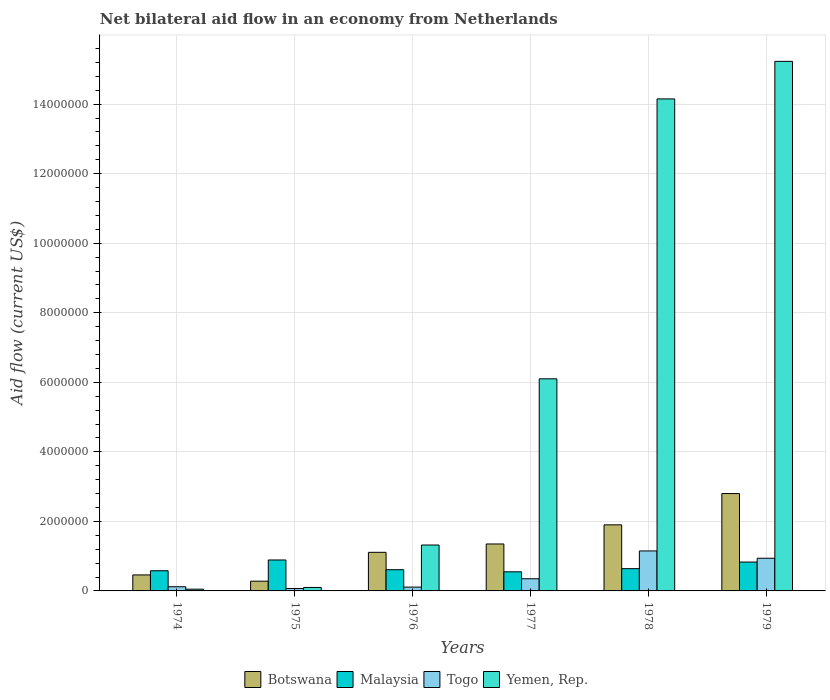Are the number of bars per tick equal to the number of legend labels?
Your answer should be compact. Yes. Are the number of bars on each tick of the X-axis equal?
Your response must be concise. Yes. How many bars are there on the 3rd tick from the left?
Ensure brevity in your answer.  4. How many bars are there on the 6th tick from the right?
Offer a terse response. 4. What is the label of the 2nd group of bars from the left?
Your answer should be compact. 1975. In how many cases, is the number of bars for a given year not equal to the number of legend labels?
Your answer should be compact. 0. Across all years, what is the maximum net bilateral aid flow in Togo?
Your answer should be compact. 1.15e+06. Across all years, what is the minimum net bilateral aid flow in Botswana?
Give a very brief answer. 2.80e+05. In which year was the net bilateral aid flow in Botswana maximum?
Provide a short and direct response. 1979. In which year was the net bilateral aid flow in Yemen, Rep. minimum?
Provide a short and direct response. 1974. What is the total net bilateral aid flow in Malaysia in the graph?
Your response must be concise. 4.10e+06. What is the difference between the net bilateral aid flow in Malaysia in 1975 and that in 1977?
Make the answer very short. 3.40e+05. What is the difference between the net bilateral aid flow in Togo in 1978 and the net bilateral aid flow in Botswana in 1979?
Make the answer very short. -1.65e+06. What is the average net bilateral aid flow in Togo per year?
Offer a terse response. 4.57e+05. What is the ratio of the net bilateral aid flow in Botswana in 1974 to that in 1978?
Your answer should be very brief. 0.24. Is the difference between the net bilateral aid flow in Malaysia in 1975 and 1977 greater than the difference between the net bilateral aid flow in Togo in 1975 and 1977?
Ensure brevity in your answer.  Yes. What is the difference between the highest and the second highest net bilateral aid flow in Yemen, Rep.?
Your answer should be very brief. 1.08e+06. What is the difference between the highest and the lowest net bilateral aid flow in Botswana?
Offer a terse response. 2.52e+06. In how many years, is the net bilateral aid flow in Botswana greater than the average net bilateral aid flow in Botswana taken over all years?
Provide a short and direct response. 3. Is the sum of the net bilateral aid flow in Botswana in 1974 and 1977 greater than the maximum net bilateral aid flow in Malaysia across all years?
Give a very brief answer. Yes. What does the 3rd bar from the left in 1979 represents?
Offer a very short reply. Togo. What does the 3rd bar from the right in 1979 represents?
Your answer should be compact. Malaysia. How many bars are there?
Offer a very short reply. 24. How many years are there in the graph?
Provide a short and direct response. 6. What is the difference between two consecutive major ticks on the Y-axis?
Ensure brevity in your answer.  2.00e+06. Are the values on the major ticks of Y-axis written in scientific E-notation?
Provide a short and direct response. No. What is the title of the graph?
Give a very brief answer. Net bilateral aid flow in an economy from Netherlands. What is the label or title of the Y-axis?
Your answer should be very brief. Aid flow (current US$). What is the Aid flow (current US$) of Botswana in 1974?
Offer a terse response. 4.60e+05. What is the Aid flow (current US$) in Malaysia in 1974?
Your response must be concise. 5.80e+05. What is the Aid flow (current US$) of Togo in 1974?
Your response must be concise. 1.20e+05. What is the Aid flow (current US$) of Yemen, Rep. in 1974?
Offer a terse response. 5.00e+04. What is the Aid flow (current US$) of Botswana in 1975?
Provide a succinct answer. 2.80e+05. What is the Aid flow (current US$) in Malaysia in 1975?
Offer a very short reply. 8.90e+05. What is the Aid flow (current US$) of Togo in 1975?
Offer a terse response. 7.00e+04. What is the Aid flow (current US$) of Botswana in 1976?
Offer a terse response. 1.11e+06. What is the Aid flow (current US$) in Yemen, Rep. in 1976?
Keep it short and to the point. 1.32e+06. What is the Aid flow (current US$) of Botswana in 1977?
Provide a short and direct response. 1.35e+06. What is the Aid flow (current US$) of Malaysia in 1977?
Keep it short and to the point. 5.50e+05. What is the Aid flow (current US$) of Yemen, Rep. in 1977?
Your answer should be very brief. 6.10e+06. What is the Aid flow (current US$) in Botswana in 1978?
Provide a succinct answer. 1.90e+06. What is the Aid flow (current US$) in Malaysia in 1978?
Provide a short and direct response. 6.40e+05. What is the Aid flow (current US$) of Togo in 1978?
Offer a very short reply. 1.15e+06. What is the Aid flow (current US$) in Yemen, Rep. in 1978?
Provide a succinct answer. 1.42e+07. What is the Aid flow (current US$) of Botswana in 1979?
Your answer should be compact. 2.80e+06. What is the Aid flow (current US$) of Malaysia in 1979?
Keep it short and to the point. 8.30e+05. What is the Aid flow (current US$) in Togo in 1979?
Offer a very short reply. 9.40e+05. What is the Aid flow (current US$) of Yemen, Rep. in 1979?
Make the answer very short. 1.52e+07. Across all years, what is the maximum Aid flow (current US$) in Botswana?
Ensure brevity in your answer.  2.80e+06. Across all years, what is the maximum Aid flow (current US$) of Malaysia?
Offer a very short reply. 8.90e+05. Across all years, what is the maximum Aid flow (current US$) in Togo?
Give a very brief answer. 1.15e+06. Across all years, what is the maximum Aid flow (current US$) of Yemen, Rep.?
Offer a very short reply. 1.52e+07. Across all years, what is the minimum Aid flow (current US$) in Botswana?
Ensure brevity in your answer.  2.80e+05. Across all years, what is the minimum Aid flow (current US$) of Togo?
Your response must be concise. 7.00e+04. What is the total Aid flow (current US$) of Botswana in the graph?
Provide a short and direct response. 7.90e+06. What is the total Aid flow (current US$) of Malaysia in the graph?
Make the answer very short. 4.10e+06. What is the total Aid flow (current US$) in Togo in the graph?
Offer a terse response. 2.74e+06. What is the total Aid flow (current US$) in Yemen, Rep. in the graph?
Provide a succinct answer. 3.70e+07. What is the difference between the Aid flow (current US$) of Botswana in 1974 and that in 1975?
Provide a short and direct response. 1.80e+05. What is the difference between the Aid flow (current US$) in Malaysia in 1974 and that in 1975?
Give a very brief answer. -3.10e+05. What is the difference between the Aid flow (current US$) in Botswana in 1974 and that in 1976?
Your answer should be compact. -6.50e+05. What is the difference between the Aid flow (current US$) of Malaysia in 1974 and that in 1976?
Your answer should be very brief. -3.00e+04. What is the difference between the Aid flow (current US$) of Yemen, Rep. in 1974 and that in 1976?
Offer a terse response. -1.27e+06. What is the difference between the Aid flow (current US$) of Botswana in 1974 and that in 1977?
Keep it short and to the point. -8.90e+05. What is the difference between the Aid flow (current US$) in Yemen, Rep. in 1974 and that in 1977?
Offer a very short reply. -6.05e+06. What is the difference between the Aid flow (current US$) of Botswana in 1974 and that in 1978?
Keep it short and to the point. -1.44e+06. What is the difference between the Aid flow (current US$) of Togo in 1974 and that in 1978?
Your answer should be very brief. -1.03e+06. What is the difference between the Aid flow (current US$) in Yemen, Rep. in 1974 and that in 1978?
Your answer should be compact. -1.41e+07. What is the difference between the Aid flow (current US$) in Botswana in 1974 and that in 1979?
Your answer should be very brief. -2.34e+06. What is the difference between the Aid flow (current US$) in Togo in 1974 and that in 1979?
Provide a succinct answer. -8.20e+05. What is the difference between the Aid flow (current US$) of Yemen, Rep. in 1974 and that in 1979?
Give a very brief answer. -1.52e+07. What is the difference between the Aid flow (current US$) in Botswana in 1975 and that in 1976?
Offer a terse response. -8.30e+05. What is the difference between the Aid flow (current US$) of Malaysia in 1975 and that in 1976?
Keep it short and to the point. 2.80e+05. What is the difference between the Aid flow (current US$) in Yemen, Rep. in 1975 and that in 1976?
Your answer should be very brief. -1.22e+06. What is the difference between the Aid flow (current US$) in Botswana in 1975 and that in 1977?
Offer a very short reply. -1.07e+06. What is the difference between the Aid flow (current US$) in Malaysia in 1975 and that in 1977?
Make the answer very short. 3.40e+05. What is the difference between the Aid flow (current US$) in Togo in 1975 and that in 1977?
Your response must be concise. -2.80e+05. What is the difference between the Aid flow (current US$) in Yemen, Rep. in 1975 and that in 1977?
Your response must be concise. -6.00e+06. What is the difference between the Aid flow (current US$) in Botswana in 1975 and that in 1978?
Offer a terse response. -1.62e+06. What is the difference between the Aid flow (current US$) of Malaysia in 1975 and that in 1978?
Provide a short and direct response. 2.50e+05. What is the difference between the Aid flow (current US$) of Togo in 1975 and that in 1978?
Offer a terse response. -1.08e+06. What is the difference between the Aid flow (current US$) of Yemen, Rep. in 1975 and that in 1978?
Offer a very short reply. -1.40e+07. What is the difference between the Aid flow (current US$) in Botswana in 1975 and that in 1979?
Provide a succinct answer. -2.52e+06. What is the difference between the Aid flow (current US$) of Togo in 1975 and that in 1979?
Offer a terse response. -8.70e+05. What is the difference between the Aid flow (current US$) of Yemen, Rep. in 1975 and that in 1979?
Offer a very short reply. -1.51e+07. What is the difference between the Aid flow (current US$) in Botswana in 1976 and that in 1977?
Offer a terse response. -2.40e+05. What is the difference between the Aid flow (current US$) in Yemen, Rep. in 1976 and that in 1977?
Make the answer very short. -4.78e+06. What is the difference between the Aid flow (current US$) of Botswana in 1976 and that in 1978?
Provide a short and direct response. -7.90e+05. What is the difference between the Aid flow (current US$) in Togo in 1976 and that in 1978?
Your response must be concise. -1.04e+06. What is the difference between the Aid flow (current US$) in Yemen, Rep. in 1976 and that in 1978?
Offer a terse response. -1.28e+07. What is the difference between the Aid flow (current US$) of Botswana in 1976 and that in 1979?
Your answer should be very brief. -1.69e+06. What is the difference between the Aid flow (current US$) of Malaysia in 1976 and that in 1979?
Your answer should be very brief. -2.20e+05. What is the difference between the Aid flow (current US$) in Togo in 1976 and that in 1979?
Offer a terse response. -8.30e+05. What is the difference between the Aid flow (current US$) in Yemen, Rep. in 1976 and that in 1979?
Your answer should be very brief. -1.39e+07. What is the difference between the Aid flow (current US$) of Botswana in 1977 and that in 1978?
Provide a short and direct response. -5.50e+05. What is the difference between the Aid flow (current US$) of Togo in 1977 and that in 1978?
Your answer should be compact. -8.00e+05. What is the difference between the Aid flow (current US$) in Yemen, Rep. in 1977 and that in 1978?
Ensure brevity in your answer.  -8.05e+06. What is the difference between the Aid flow (current US$) in Botswana in 1977 and that in 1979?
Provide a succinct answer. -1.45e+06. What is the difference between the Aid flow (current US$) of Malaysia in 1977 and that in 1979?
Make the answer very short. -2.80e+05. What is the difference between the Aid flow (current US$) in Togo in 1977 and that in 1979?
Give a very brief answer. -5.90e+05. What is the difference between the Aid flow (current US$) in Yemen, Rep. in 1977 and that in 1979?
Provide a short and direct response. -9.13e+06. What is the difference between the Aid flow (current US$) in Botswana in 1978 and that in 1979?
Provide a short and direct response. -9.00e+05. What is the difference between the Aid flow (current US$) in Malaysia in 1978 and that in 1979?
Keep it short and to the point. -1.90e+05. What is the difference between the Aid flow (current US$) in Togo in 1978 and that in 1979?
Your answer should be very brief. 2.10e+05. What is the difference between the Aid flow (current US$) of Yemen, Rep. in 1978 and that in 1979?
Your answer should be very brief. -1.08e+06. What is the difference between the Aid flow (current US$) of Botswana in 1974 and the Aid flow (current US$) of Malaysia in 1975?
Keep it short and to the point. -4.30e+05. What is the difference between the Aid flow (current US$) in Botswana in 1974 and the Aid flow (current US$) in Togo in 1975?
Ensure brevity in your answer.  3.90e+05. What is the difference between the Aid flow (current US$) of Malaysia in 1974 and the Aid flow (current US$) of Togo in 1975?
Your response must be concise. 5.10e+05. What is the difference between the Aid flow (current US$) of Togo in 1974 and the Aid flow (current US$) of Yemen, Rep. in 1975?
Offer a very short reply. 2.00e+04. What is the difference between the Aid flow (current US$) in Botswana in 1974 and the Aid flow (current US$) in Yemen, Rep. in 1976?
Offer a very short reply. -8.60e+05. What is the difference between the Aid flow (current US$) of Malaysia in 1974 and the Aid flow (current US$) of Togo in 1976?
Your response must be concise. 4.70e+05. What is the difference between the Aid flow (current US$) in Malaysia in 1974 and the Aid flow (current US$) in Yemen, Rep. in 1976?
Offer a very short reply. -7.40e+05. What is the difference between the Aid flow (current US$) of Togo in 1974 and the Aid flow (current US$) of Yemen, Rep. in 1976?
Your response must be concise. -1.20e+06. What is the difference between the Aid flow (current US$) in Botswana in 1974 and the Aid flow (current US$) in Togo in 1977?
Offer a terse response. 1.10e+05. What is the difference between the Aid flow (current US$) in Botswana in 1974 and the Aid flow (current US$) in Yemen, Rep. in 1977?
Your answer should be compact. -5.64e+06. What is the difference between the Aid flow (current US$) in Malaysia in 1974 and the Aid flow (current US$) in Togo in 1977?
Your answer should be very brief. 2.30e+05. What is the difference between the Aid flow (current US$) in Malaysia in 1974 and the Aid flow (current US$) in Yemen, Rep. in 1977?
Your response must be concise. -5.52e+06. What is the difference between the Aid flow (current US$) of Togo in 1974 and the Aid flow (current US$) of Yemen, Rep. in 1977?
Keep it short and to the point. -5.98e+06. What is the difference between the Aid flow (current US$) of Botswana in 1974 and the Aid flow (current US$) of Malaysia in 1978?
Give a very brief answer. -1.80e+05. What is the difference between the Aid flow (current US$) in Botswana in 1974 and the Aid flow (current US$) in Togo in 1978?
Provide a short and direct response. -6.90e+05. What is the difference between the Aid flow (current US$) of Botswana in 1974 and the Aid flow (current US$) of Yemen, Rep. in 1978?
Keep it short and to the point. -1.37e+07. What is the difference between the Aid flow (current US$) in Malaysia in 1974 and the Aid flow (current US$) in Togo in 1978?
Your answer should be compact. -5.70e+05. What is the difference between the Aid flow (current US$) of Malaysia in 1974 and the Aid flow (current US$) of Yemen, Rep. in 1978?
Offer a very short reply. -1.36e+07. What is the difference between the Aid flow (current US$) in Togo in 1974 and the Aid flow (current US$) in Yemen, Rep. in 1978?
Keep it short and to the point. -1.40e+07. What is the difference between the Aid flow (current US$) in Botswana in 1974 and the Aid flow (current US$) in Malaysia in 1979?
Your response must be concise. -3.70e+05. What is the difference between the Aid flow (current US$) of Botswana in 1974 and the Aid flow (current US$) of Togo in 1979?
Provide a succinct answer. -4.80e+05. What is the difference between the Aid flow (current US$) of Botswana in 1974 and the Aid flow (current US$) of Yemen, Rep. in 1979?
Provide a short and direct response. -1.48e+07. What is the difference between the Aid flow (current US$) in Malaysia in 1974 and the Aid flow (current US$) in Togo in 1979?
Your answer should be very brief. -3.60e+05. What is the difference between the Aid flow (current US$) in Malaysia in 1974 and the Aid flow (current US$) in Yemen, Rep. in 1979?
Ensure brevity in your answer.  -1.46e+07. What is the difference between the Aid flow (current US$) of Togo in 1974 and the Aid flow (current US$) of Yemen, Rep. in 1979?
Make the answer very short. -1.51e+07. What is the difference between the Aid flow (current US$) of Botswana in 1975 and the Aid flow (current US$) of Malaysia in 1976?
Provide a short and direct response. -3.30e+05. What is the difference between the Aid flow (current US$) of Botswana in 1975 and the Aid flow (current US$) of Togo in 1976?
Your answer should be very brief. 1.70e+05. What is the difference between the Aid flow (current US$) in Botswana in 1975 and the Aid flow (current US$) in Yemen, Rep. in 1976?
Give a very brief answer. -1.04e+06. What is the difference between the Aid flow (current US$) of Malaysia in 1975 and the Aid flow (current US$) of Togo in 1976?
Ensure brevity in your answer.  7.80e+05. What is the difference between the Aid flow (current US$) in Malaysia in 1975 and the Aid flow (current US$) in Yemen, Rep. in 1976?
Provide a short and direct response. -4.30e+05. What is the difference between the Aid flow (current US$) in Togo in 1975 and the Aid flow (current US$) in Yemen, Rep. in 1976?
Keep it short and to the point. -1.25e+06. What is the difference between the Aid flow (current US$) of Botswana in 1975 and the Aid flow (current US$) of Malaysia in 1977?
Your response must be concise. -2.70e+05. What is the difference between the Aid flow (current US$) of Botswana in 1975 and the Aid flow (current US$) of Togo in 1977?
Make the answer very short. -7.00e+04. What is the difference between the Aid flow (current US$) in Botswana in 1975 and the Aid flow (current US$) in Yemen, Rep. in 1977?
Ensure brevity in your answer.  -5.82e+06. What is the difference between the Aid flow (current US$) in Malaysia in 1975 and the Aid flow (current US$) in Togo in 1977?
Keep it short and to the point. 5.40e+05. What is the difference between the Aid flow (current US$) of Malaysia in 1975 and the Aid flow (current US$) of Yemen, Rep. in 1977?
Make the answer very short. -5.21e+06. What is the difference between the Aid flow (current US$) in Togo in 1975 and the Aid flow (current US$) in Yemen, Rep. in 1977?
Provide a short and direct response. -6.03e+06. What is the difference between the Aid flow (current US$) in Botswana in 1975 and the Aid flow (current US$) in Malaysia in 1978?
Make the answer very short. -3.60e+05. What is the difference between the Aid flow (current US$) of Botswana in 1975 and the Aid flow (current US$) of Togo in 1978?
Your answer should be compact. -8.70e+05. What is the difference between the Aid flow (current US$) in Botswana in 1975 and the Aid flow (current US$) in Yemen, Rep. in 1978?
Give a very brief answer. -1.39e+07. What is the difference between the Aid flow (current US$) in Malaysia in 1975 and the Aid flow (current US$) in Yemen, Rep. in 1978?
Give a very brief answer. -1.33e+07. What is the difference between the Aid flow (current US$) in Togo in 1975 and the Aid flow (current US$) in Yemen, Rep. in 1978?
Provide a short and direct response. -1.41e+07. What is the difference between the Aid flow (current US$) in Botswana in 1975 and the Aid flow (current US$) in Malaysia in 1979?
Ensure brevity in your answer.  -5.50e+05. What is the difference between the Aid flow (current US$) of Botswana in 1975 and the Aid flow (current US$) of Togo in 1979?
Offer a very short reply. -6.60e+05. What is the difference between the Aid flow (current US$) of Botswana in 1975 and the Aid flow (current US$) of Yemen, Rep. in 1979?
Provide a succinct answer. -1.50e+07. What is the difference between the Aid flow (current US$) of Malaysia in 1975 and the Aid flow (current US$) of Yemen, Rep. in 1979?
Provide a succinct answer. -1.43e+07. What is the difference between the Aid flow (current US$) in Togo in 1975 and the Aid flow (current US$) in Yemen, Rep. in 1979?
Your answer should be compact. -1.52e+07. What is the difference between the Aid flow (current US$) of Botswana in 1976 and the Aid flow (current US$) of Malaysia in 1977?
Ensure brevity in your answer.  5.60e+05. What is the difference between the Aid flow (current US$) of Botswana in 1976 and the Aid flow (current US$) of Togo in 1977?
Your response must be concise. 7.60e+05. What is the difference between the Aid flow (current US$) in Botswana in 1976 and the Aid flow (current US$) in Yemen, Rep. in 1977?
Your response must be concise. -4.99e+06. What is the difference between the Aid flow (current US$) of Malaysia in 1976 and the Aid flow (current US$) of Yemen, Rep. in 1977?
Your answer should be compact. -5.49e+06. What is the difference between the Aid flow (current US$) in Togo in 1976 and the Aid flow (current US$) in Yemen, Rep. in 1977?
Give a very brief answer. -5.99e+06. What is the difference between the Aid flow (current US$) of Botswana in 1976 and the Aid flow (current US$) of Malaysia in 1978?
Your response must be concise. 4.70e+05. What is the difference between the Aid flow (current US$) of Botswana in 1976 and the Aid flow (current US$) of Yemen, Rep. in 1978?
Offer a very short reply. -1.30e+07. What is the difference between the Aid flow (current US$) in Malaysia in 1976 and the Aid flow (current US$) in Togo in 1978?
Give a very brief answer. -5.40e+05. What is the difference between the Aid flow (current US$) in Malaysia in 1976 and the Aid flow (current US$) in Yemen, Rep. in 1978?
Offer a terse response. -1.35e+07. What is the difference between the Aid flow (current US$) of Togo in 1976 and the Aid flow (current US$) of Yemen, Rep. in 1978?
Your answer should be compact. -1.40e+07. What is the difference between the Aid flow (current US$) in Botswana in 1976 and the Aid flow (current US$) in Malaysia in 1979?
Give a very brief answer. 2.80e+05. What is the difference between the Aid flow (current US$) in Botswana in 1976 and the Aid flow (current US$) in Yemen, Rep. in 1979?
Keep it short and to the point. -1.41e+07. What is the difference between the Aid flow (current US$) of Malaysia in 1976 and the Aid flow (current US$) of Togo in 1979?
Provide a succinct answer. -3.30e+05. What is the difference between the Aid flow (current US$) of Malaysia in 1976 and the Aid flow (current US$) of Yemen, Rep. in 1979?
Provide a succinct answer. -1.46e+07. What is the difference between the Aid flow (current US$) of Togo in 1976 and the Aid flow (current US$) of Yemen, Rep. in 1979?
Offer a terse response. -1.51e+07. What is the difference between the Aid flow (current US$) of Botswana in 1977 and the Aid flow (current US$) of Malaysia in 1978?
Offer a terse response. 7.10e+05. What is the difference between the Aid flow (current US$) of Botswana in 1977 and the Aid flow (current US$) of Yemen, Rep. in 1978?
Make the answer very short. -1.28e+07. What is the difference between the Aid flow (current US$) in Malaysia in 1977 and the Aid flow (current US$) in Togo in 1978?
Your answer should be compact. -6.00e+05. What is the difference between the Aid flow (current US$) in Malaysia in 1977 and the Aid flow (current US$) in Yemen, Rep. in 1978?
Your answer should be very brief. -1.36e+07. What is the difference between the Aid flow (current US$) of Togo in 1977 and the Aid flow (current US$) of Yemen, Rep. in 1978?
Make the answer very short. -1.38e+07. What is the difference between the Aid flow (current US$) of Botswana in 1977 and the Aid flow (current US$) of Malaysia in 1979?
Ensure brevity in your answer.  5.20e+05. What is the difference between the Aid flow (current US$) in Botswana in 1977 and the Aid flow (current US$) in Togo in 1979?
Give a very brief answer. 4.10e+05. What is the difference between the Aid flow (current US$) in Botswana in 1977 and the Aid flow (current US$) in Yemen, Rep. in 1979?
Your answer should be compact. -1.39e+07. What is the difference between the Aid flow (current US$) of Malaysia in 1977 and the Aid flow (current US$) of Togo in 1979?
Offer a very short reply. -3.90e+05. What is the difference between the Aid flow (current US$) of Malaysia in 1977 and the Aid flow (current US$) of Yemen, Rep. in 1979?
Provide a succinct answer. -1.47e+07. What is the difference between the Aid flow (current US$) of Togo in 1977 and the Aid flow (current US$) of Yemen, Rep. in 1979?
Your answer should be very brief. -1.49e+07. What is the difference between the Aid flow (current US$) in Botswana in 1978 and the Aid flow (current US$) in Malaysia in 1979?
Provide a short and direct response. 1.07e+06. What is the difference between the Aid flow (current US$) of Botswana in 1978 and the Aid flow (current US$) of Togo in 1979?
Ensure brevity in your answer.  9.60e+05. What is the difference between the Aid flow (current US$) in Botswana in 1978 and the Aid flow (current US$) in Yemen, Rep. in 1979?
Give a very brief answer. -1.33e+07. What is the difference between the Aid flow (current US$) of Malaysia in 1978 and the Aid flow (current US$) of Togo in 1979?
Offer a terse response. -3.00e+05. What is the difference between the Aid flow (current US$) of Malaysia in 1978 and the Aid flow (current US$) of Yemen, Rep. in 1979?
Keep it short and to the point. -1.46e+07. What is the difference between the Aid flow (current US$) in Togo in 1978 and the Aid flow (current US$) in Yemen, Rep. in 1979?
Provide a short and direct response. -1.41e+07. What is the average Aid flow (current US$) in Botswana per year?
Make the answer very short. 1.32e+06. What is the average Aid flow (current US$) in Malaysia per year?
Ensure brevity in your answer.  6.83e+05. What is the average Aid flow (current US$) of Togo per year?
Provide a short and direct response. 4.57e+05. What is the average Aid flow (current US$) of Yemen, Rep. per year?
Provide a short and direct response. 6.16e+06. In the year 1974, what is the difference between the Aid flow (current US$) of Botswana and Aid flow (current US$) of Malaysia?
Your answer should be compact. -1.20e+05. In the year 1974, what is the difference between the Aid flow (current US$) of Botswana and Aid flow (current US$) of Yemen, Rep.?
Keep it short and to the point. 4.10e+05. In the year 1974, what is the difference between the Aid flow (current US$) in Malaysia and Aid flow (current US$) in Togo?
Your response must be concise. 4.60e+05. In the year 1974, what is the difference between the Aid flow (current US$) in Malaysia and Aid flow (current US$) in Yemen, Rep.?
Offer a terse response. 5.30e+05. In the year 1974, what is the difference between the Aid flow (current US$) of Togo and Aid flow (current US$) of Yemen, Rep.?
Give a very brief answer. 7.00e+04. In the year 1975, what is the difference between the Aid flow (current US$) of Botswana and Aid flow (current US$) of Malaysia?
Your response must be concise. -6.10e+05. In the year 1975, what is the difference between the Aid flow (current US$) in Malaysia and Aid flow (current US$) in Togo?
Ensure brevity in your answer.  8.20e+05. In the year 1975, what is the difference between the Aid flow (current US$) of Malaysia and Aid flow (current US$) of Yemen, Rep.?
Provide a short and direct response. 7.90e+05. In the year 1975, what is the difference between the Aid flow (current US$) in Togo and Aid flow (current US$) in Yemen, Rep.?
Give a very brief answer. -3.00e+04. In the year 1976, what is the difference between the Aid flow (current US$) in Botswana and Aid flow (current US$) in Togo?
Ensure brevity in your answer.  1.00e+06. In the year 1976, what is the difference between the Aid flow (current US$) in Botswana and Aid flow (current US$) in Yemen, Rep.?
Offer a terse response. -2.10e+05. In the year 1976, what is the difference between the Aid flow (current US$) of Malaysia and Aid flow (current US$) of Yemen, Rep.?
Make the answer very short. -7.10e+05. In the year 1976, what is the difference between the Aid flow (current US$) in Togo and Aid flow (current US$) in Yemen, Rep.?
Give a very brief answer. -1.21e+06. In the year 1977, what is the difference between the Aid flow (current US$) in Botswana and Aid flow (current US$) in Malaysia?
Ensure brevity in your answer.  8.00e+05. In the year 1977, what is the difference between the Aid flow (current US$) in Botswana and Aid flow (current US$) in Togo?
Give a very brief answer. 1.00e+06. In the year 1977, what is the difference between the Aid flow (current US$) of Botswana and Aid flow (current US$) of Yemen, Rep.?
Provide a short and direct response. -4.75e+06. In the year 1977, what is the difference between the Aid flow (current US$) of Malaysia and Aid flow (current US$) of Yemen, Rep.?
Offer a very short reply. -5.55e+06. In the year 1977, what is the difference between the Aid flow (current US$) in Togo and Aid flow (current US$) in Yemen, Rep.?
Ensure brevity in your answer.  -5.75e+06. In the year 1978, what is the difference between the Aid flow (current US$) of Botswana and Aid flow (current US$) of Malaysia?
Your answer should be compact. 1.26e+06. In the year 1978, what is the difference between the Aid flow (current US$) of Botswana and Aid flow (current US$) of Togo?
Your answer should be compact. 7.50e+05. In the year 1978, what is the difference between the Aid flow (current US$) in Botswana and Aid flow (current US$) in Yemen, Rep.?
Your response must be concise. -1.22e+07. In the year 1978, what is the difference between the Aid flow (current US$) of Malaysia and Aid flow (current US$) of Togo?
Provide a succinct answer. -5.10e+05. In the year 1978, what is the difference between the Aid flow (current US$) in Malaysia and Aid flow (current US$) in Yemen, Rep.?
Offer a terse response. -1.35e+07. In the year 1978, what is the difference between the Aid flow (current US$) of Togo and Aid flow (current US$) of Yemen, Rep.?
Keep it short and to the point. -1.30e+07. In the year 1979, what is the difference between the Aid flow (current US$) in Botswana and Aid flow (current US$) in Malaysia?
Give a very brief answer. 1.97e+06. In the year 1979, what is the difference between the Aid flow (current US$) in Botswana and Aid flow (current US$) in Togo?
Provide a short and direct response. 1.86e+06. In the year 1979, what is the difference between the Aid flow (current US$) of Botswana and Aid flow (current US$) of Yemen, Rep.?
Your answer should be compact. -1.24e+07. In the year 1979, what is the difference between the Aid flow (current US$) in Malaysia and Aid flow (current US$) in Yemen, Rep.?
Provide a short and direct response. -1.44e+07. In the year 1979, what is the difference between the Aid flow (current US$) of Togo and Aid flow (current US$) of Yemen, Rep.?
Make the answer very short. -1.43e+07. What is the ratio of the Aid flow (current US$) in Botswana in 1974 to that in 1975?
Offer a very short reply. 1.64. What is the ratio of the Aid flow (current US$) in Malaysia in 1974 to that in 1975?
Make the answer very short. 0.65. What is the ratio of the Aid flow (current US$) of Togo in 1974 to that in 1975?
Your response must be concise. 1.71. What is the ratio of the Aid flow (current US$) in Yemen, Rep. in 1974 to that in 1975?
Keep it short and to the point. 0.5. What is the ratio of the Aid flow (current US$) in Botswana in 1974 to that in 1976?
Keep it short and to the point. 0.41. What is the ratio of the Aid flow (current US$) in Malaysia in 1974 to that in 1976?
Your response must be concise. 0.95. What is the ratio of the Aid flow (current US$) of Togo in 1974 to that in 1976?
Give a very brief answer. 1.09. What is the ratio of the Aid flow (current US$) of Yemen, Rep. in 1974 to that in 1976?
Your response must be concise. 0.04. What is the ratio of the Aid flow (current US$) in Botswana in 1974 to that in 1977?
Ensure brevity in your answer.  0.34. What is the ratio of the Aid flow (current US$) of Malaysia in 1974 to that in 1977?
Provide a short and direct response. 1.05. What is the ratio of the Aid flow (current US$) of Togo in 1974 to that in 1977?
Keep it short and to the point. 0.34. What is the ratio of the Aid flow (current US$) of Yemen, Rep. in 1974 to that in 1977?
Keep it short and to the point. 0.01. What is the ratio of the Aid flow (current US$) in Botswana in 1974 to that in 1978?
Offer a very short reply. 0.24. What is the ratio of the Aid flow (current US$) in Malaysia in 1974 to that in 1978?
Keep it short and to the point. 0.91. What is the ratio of the Aid flow (current US$) of Togo in 1974 to that in 1978?
Ensure brevity in your answer.  0.1. What is the ratio of the Aid flow (current US$) of Yemen, Rep. in 1974 to that in 1978?
Your response must be concise. 0. What is the ratio of the Aid flow (current US$) of Botswana in 1974 to that in 1979?
Offer a terse response. 0.16. What is the ratio of the Aid flow (current US$) in Malaysia in 1974 to that in 1979?
Give a very brief answer. 0.7. What is the ratio of the Aid flow (current US$) of Togo in 1974 to that in 1979?
Make the answer very short. 0.13. What is the ratio of the Aid flow (current US$) of Yemen, Rep. in 1974 to that in 1979?
Keep it short and to the point. 0. What is the ratio of the Aid flow (current US$) in Botswana in 1975 to that in 1976?
Make the answer very short. 0.25. What is the ratio of the Aid flow (current US$) of Malaysia in 1975 to that in 1976?
Your answer should be very brief. 1.46. What is the ratio of the Aid flow (current US$) in Togo in 1975 to that in 1976?
Offer a terse response. 0.64. What is the ratio of the Aid flow (current US$) of Yemen, Rep. in 1975 to that in 1976?
Ensure brevity in your answer.  0.08. What is the ratio of the Aid flow (current US$) in Botswana in 1975 to that in 1977?
Keep it short and to the point. 0.21. What is the ratio of the Aid flow (current US$) of Malaysia in 1975 to that in 1977?
Provide a succinct answer. 1.62. What is the ratio of the Aid flow (current US$) of Yemen, Rep. in 1975 to that in 1977?
Your answer should be very brief. 0.02. What is the ratio of the Aid flow (current US$) in Botswana in 1975 to that in 1978?
Ensure brevity in your answer.  0.15. What is the ratio of the Aid flow (current US$) in Malaysia in 1975 to that in 1978?
Your answer should be very brief. 1.39. What is the ratio of the Aid flow (current US$) of Togo in 1975 to that in 1978?
Your answer should be compact. 0.06. What is the ratio of the Aid flow (current US$) of Yemen, Rep. in 1975 to that in 1978?
Give a very brief answer. 0.01. What is the ratio of the Aid flow (current US$) of Botswana in 1975 to that in 1979?
Your answer should be compact. 0.1. What is the ratio of the Aid flow (current US$) of Malaysia in 1975 to that in 1979?
Keep it short and to the point. 1.07. What is the ratio of the Aid flow (current US$) in Togo in 1975 to that in 1979?
Ensure brevity in your answer.  0.07. What is the ratio of the Aid flow (current US$) of Yemen, Rep. in 1975 to that in 1979?
Your answer should be very brief. 0.01. What is the ratio of the Aid flow (current US$) in Botswana in 1976 to that in 1977?
Provide a succinct answer. 0.82. What is the ratio of the Aid flow (current US$) of Malaysia in 1976 to that in 1977?
Provide a short and direct response. 1.11. What is the ratio of the Aid flow (current US$) of Togo in 1976 to that in 1977?
Offer a very short reply. 0.31. What is the ratio of the Aid flow (current US$) of Yemen, Rep. in 1976 to that in 1977?
Offer a terse response. 0.22. What is the ratio of the Aid flow (current US$) in Botswana in 1976 to that in 1978?
Your answer should be compact. 0.58. What is the ratio of the Aid flow (current US$) of Malaysia in 1976 to that in 1978?
Your answer should be compact. 0.95. What is the ratio of the Aid flow (current US$) in Togo in 1976 to that in 1978?
Make the answer very short. 0.1. What is the ratio of the Aid flow (current US$) in Yemen, Rep. in 1976 to that in 1978?
Make the answer very short. 0.09. What is the ratio of the Aid flow (current US$) in Botswana in 1976 to that in 1979?
Your answer should be compact. 0.4. What is the ratio of the Aid flow (current US$) of Malaysia in 1976 to that in 1979?
Give a very brief answer. 0.73. What is the ratio of the Aid flow (current US$) in Togo in 1976 to that in 1979?
Offer a terse response. 0.12. What is the ratio of the Aid flow (current US$) of Yemen, Rep. in 1976 to that in 1979?
Offer a very short reply. 0.09. What is the ratio of the Aid flow (current US$) in Botswana in 1977 to that in 1978?
Your answer should be compact. 0.71. What is the ratio of the Aid flow (current US$) in Malaysia in 1977 to that in 1978?
Keep it short and to the point. 0.86. What is the ratio of the Aid flow (current US$) of Togo in 1977 to that in 1978?
Keep it short and to the point. 0.3. What is the ratio of the Aid flow (current US$) in Yemen, Rep. in 1977 to that in 1978?
Keep it short and to the point. 0.43. What is the ratio of the Aid flow (current US$) of Botswana in 1977 to that in 1979?
Your response must be concise. 0.48. What is the ratio of the Aid flow (current US$) in Malaysia in 1977 to that in 1979?
Make the answer very short. 0.66. What is the ratio of the Aid flow (current US$) of Togo in 1977 to that in 1979?
Make the answer very short. 0.37. What is the ratio of the Aid flow (current US$) of Yemen, Rep. in 1977 to that in 1979?
Keep it short and to the point. 0.4. What is the ratio of the Aid flow (current US$) of Botswana in 1978 to that in 1979?
Offer a very short reply. 0.68. What is the ratio of the Aid flow (current US$) of Malaysia in 1978 to that in 1979?
Your answer should be very brief. 0.77. What is the ratio of the Aid flow (current US$) in Togo in 1978 to that in 1979?
Provide a short and direct response. 1.22. What is the ratio of the Aid flow (current US$) of Yemen, Rep. in 1978 to that in 1979?
Your answer should be very brief. 0.93. What is the difference between the highest and the second highest Aid flow (current US$) in Togo?
Your response must be concise. 2.10e+05. What is the difference between the highest and the second highest Aid flow (current US$) in Yemen, Rep.?
Provide a succinct answer. 1.08e+06. What is the difference between the highest and the lowest Aid flow (current US$) of Botswana?
Make the answer very short. 2.52e+06. What is the difference between the highest and the lowest Aid flow (current US$) of Togo?
Your response must be concise. 1.08e+06. What is the difference between the highest and the lowest Aid flow (current US$) of Yemen, Rep.?
Your response must be concise. 1.52e+07. 